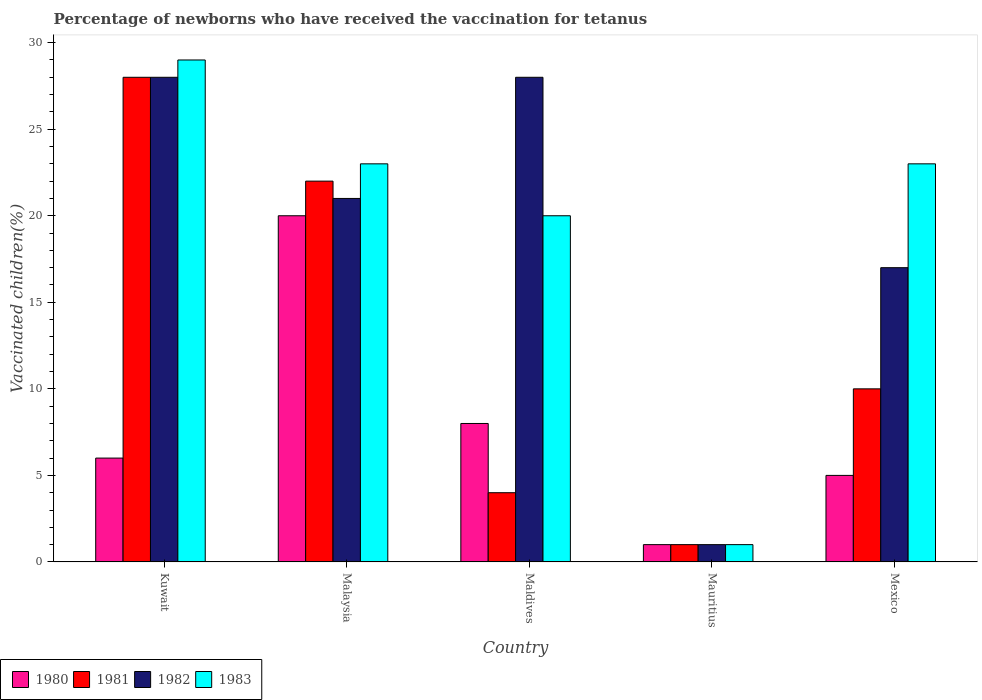How many different coloured bars are there?
Ensure brevity in your answer.  4. How many bars are there on the 3rd tick from the left?
Your answer should be compact. 4. What is the label of the 2nd group of bars from the left?
Make the answer very short. Malaysia. What is the percentage of vaccinated children in 1982 in Malaysia?
Ensure brevity in your answer.  21. Across all countries, what is the maximum percentage of vaccinated children in 1980?
Offer a very short reply. 20. In which country was the percentage of vaccinated children in 1980 maximum?
Offer a terse response. Malaysia. In which country was the percentage of vaccinated children in 1983 minimum?
Make the answer very short. Mauritius. What is the difference between the percentage of vaccinated children in 1983 in Malaysia and that in Mexico?
Your answer should be compact. 0. What is the ratio of the percentage of vaccinated children in 1983 in Maldives to that in Mexico?
Your answer should be compact. 0.87. Is the percentage of vaccinated children in 1982 in Malaysia less than that in Maldives?
Provide a short and direct response. Yes. Is the difference between the percentage of vaccinated children in 1981 in Kuwait and Mauritius greater than the difference between the percentage of vaccinated children in 1983 in Kuwait and Mauritius?
Make the answer very short. No. What is the difference between the highest and the second highest percentage of vaccinated children in 1981?
Provide a succinct answer. -18. What does the 3rd bar from the left in Mauritius represents?
Your response must be concise. 1982. What does the 4th bar from the right in Kuwait represents?
Provide a short and direct response. 1980. How many countries are there in the graph?
Provide a succinct answer. 5. What is the difference between two consecutive major ticks on the Y-axis?
Your answer should be very brief. 5. Are the values on the major ticks of Y-axis written in scientific E-notation?
Offer a terse response. No. Does the graph contain any zero values?
Make the answer very short. No. Does the graph contain grids?
Provide a short and direct response. No. Where does the legend appear in the graph?
Your answer should be very brief. Bottom left. How many legend labels are there?
Provide a succinct answer. 4. How are the legend labels stacked?
Offer a terse response. Horizontal. What is the title of the graph?
Ensure brevity in your answer.  Percentage of newborns who have received the vaccination for tetanus. What is the label or title of the X-axis?
Provide a short and direct response. Country. What is the label or title of the Y-axis?
Provide a short and direct response. Vaccinated children(%). What is the Vaccinated children(%) in 1980 in Kuwait?
Offer a terse response. 6. What is the Vaccinated children(%) of 1982 in Kuwait?
Your answer should be very brief. 28. What is the Vaccinated children(%) of 1983 in Kuwait?
Offer a terse response. 29. What is the Vaccinated children(%) in 1980 in Malaysia?
Provide a succinct answer. 20. What is the Vaccinated children(%) of 1981 in Malaysia?
Ensure brevity in your answer.  22. What is the Vaccinated children(%) of 1982 in Malaysia?
Your answer should be compact. 21. What is the Vaccinated children(%) of 1981 in Maldives?
Your answer should be compact. 4. What is the Vaccinated children(%) of 1982 in Maldives?
Ensure brevity in your answer.  28. What is the Vaccinated children(%) of 1983 in Maldives?
Ensure brevity in your answer.  20. What is the Vaccinated children(%) of 1980 in Mauritius?
Provide a succinct answer. 1. What is the Vaccinated children(%) in 1982 in Mauritius?
Provide a succinct answer. 1. What is the Vaccinated children(%) in 1983 in Mauritius?
Ensure brevity in your answer.  1. What is the Vaccinated children(%) of 1981 in Mexico?
Keep it short and to the point. 10. What is the Vaccinated children(%) of 1982 in Mexico?
Provide a short and direct response. 17. What is the Vaccinated children(%) in 1983 in Mexico?
Your answer should be compact. 23. Across all countries, what is the maximum Vaccinated children(%) of 1981?
Offer a terse response. 28. Across all countries, what is the maximum Vaccinated children(%) of 1983?
Offer a very short reply. 29. Across all countries, what is the minimum Vaccinated children(%) in 1980?
Offer a terse response. 1. What is the total Vaccinated children(%) of 1980 in the graph?
Make the answer very short. 40. What is the total Vaccinated children(%) of 1982 in the graph?
Provide a succinct answer. 95. What is the total Vaccinated children(%) in 1983 in the graph?
Offer a terse response. 96. What is the difference between the Vaccinated children(%) of 1983 in Kuwait and that in Malaysia?
Your response must be concise. 6. What is the difference between the Vaccinated children(%) in 1980 in Kuwait and that in Maldives?
Make the answer very short. -2. What is the difference between the Vaccinated children(%) of 1981 in Kuwait and that in Maldives?
Make the answer very short. 24. What is the difference between the Vaccinated children(%) of 1983 in Kuwait and that in Maldives?
Ensure brevity in your answer.  9. What is the difference between the Vaccinated children(%) of 1983 in Kuwait and that in Mauritius?
Offer a very short reply. 28. What is the difference between the Vaccinated children(%) in 1981 in Kuwait and that in Mexico?
Make the answer very short. 18. What is the difference between the Vaccinated children(%) of 1983 in Malaysia and that in Maldives?
Your answer should be very brief. 3. What is the difference between the Vaccinated children(%) in 1980 in Malaysia and that in Mauritius?
Keep it short and to the point. 19. What is the difference between the Vaccinated children(%) in 1983 in Malaysia and that in Mauritius?
Offer a terse response. 22. What is the difference between the Vaccinated children(%) in 1980 in Malaysia and that in Mexico?
Your answer should be very brief. 15. What is the difference between the Vaccinated children(%) in 1982 in Maldives and that in Mauritius?
Provide a succinct answer. 27. What is the difference between the Vaccinated children(%) of 1980 in Maldives and that in Mexico?
Offer a terse response. 3. What is the difference between the Vaccinated children(%) of 1981 in Maldives and that in Mexico?
Your answer should be compact. -6. What is the difference between the Vaccinated children(%) of 1982 in Maldives and that in Mexico?
Your response must be concise. 11. What is the difference between the Vaccinated children(%) of 1981 in Mauritius and that in Mexico?
Make the answer very short. -9. What is the difference between the Vaccinated children(%) of 1983 in Mauritius and that in Mexico?
Keep it short and to the point. -22. What is the difference between the Vaccinated children(%) of 1980 in Kuwait and the Vaccinated children(%) of 1981 in Malaysia?
Offer a very short reply. -16. What is the difference between the Vaccinated children(%) of 1980 in Kuwait and the Vaccinated children(%) of 1982 in Malaysia?
Provide a short and direct response. -15. What is the difference between the Vaccinated children(%) of 1980 in Kuwait and the Vaccinated children(%) of 1983 in Malaysia?
Provide a succinct answer. -17. What is the difference between the Vaccinated children(%) in 1981 in Kuwait and the Vaccinated children(%) in 1982 in Malaysia?
Your answer should be very brief. 7. What is the difference between the Vaccinated children(%) in 1981 in Kuwait and the Vaccinated children(%) in 1983 in Malaysia?
Offer a very short reply. 5. What is the difference between the Vaccinated children(%) of 1982 in Kuwait and the Vaccinated children(%) of 1983 in Malaysia?
Keep it short and to the point. 5. What is the difference between the Vaccinated children(%) in 1981 in Kuwait and the Vaccinated children(%) in 1982 in Maldives?
Provide a succinct answer. 0. What is the difference between the Vaccinated children(%) in 1982 in Kuwait and the Vaccinated children(%) in 1983 in Maldives?
Provide a succinct answer. 8. What is the difference between the Vaccinated children(%) of 1980 in Kuwait and the Vaccinated children(%) of 1981 in Mauritius?
Offer a terse response. 5. What is the difference between the Vaccinated children(%) in 1980 in Kuwait and the Vaccinated children(%) in 1983 in Mauritius?
Offer a very short reply. 5. What is the difference between the Vaccinated children(%) of 1981 in Kuwait and the Vaccinated children(%) of 1982 in Mauritius?
Provide a succinct answer. 27. What is the difference between the Vaccinated children(%) in 1980 in Kuwait and the Vaccinated children(%) in 1982 in Mexico?
Make the answer very short. -11. What is the difference between the Vaccinated children(%) of 1981 in Kuwait and the Vaccinated children(%) of 1982 in Mexico?
Provide a succinct answer. 11. What is the difference between the Vaccinated children(%) of 1982 in Kuwait and the Vaccinated children(%) of 1983 in Mexico?
Provide a short and direct response. 5. What is the difference between the Vaccinated children(%) in 1980 in Malaysia and the Vaccinated children(%) in 1981 in Maldives?
Offer a terse response. 16. What is the difference between the Vaccinated children(%) in 1980 in Malaysia and the Vaccinated children(%) in 1982 in Maldives?
Provide a succinct answer. -8. What is the difference between the Vaccinated children(%) of 1980 in Malaysia and the Vaccinated children(%) of 1983 in Maldives?
Offer a very short reply. 0. What is the difference between the Vaccinated children(%) in 1981 in Malaysia and the Vaccinated children(%) in 1983 in Maldives?
Provide a succinct answer. 2. What is the difference between the Vaccinated children(%) of 1982 in Malaysia and the Vaccinated children(%) of 1983 in Maldives?
Keep it short and to the point. 1. What is the difference between the Vaccinated children(%) of 1980 in Malaysia and the Vaccinated children(%) of 1981 in Mauritius?
Provide a short and direct response. 19. What is the difference between the Vaccinated children(%) of 1980 in Malaysia and the Vaccinated children(%) of 1983 in Mauritius?
Keep it short and to the point. 19. What is the difference between the Vaccinated children(%) of 1981 in Malaysia and the Vaccinated children(%) of 1982 in Mauritius?
Your answer should be very brief. 21. What is the difference between the Vaccinated children(%) of 1980 in Malaysia and the Vaccinated children(%) of 1981 in Mexico?
Your answer should be very brief. 10. What is the difference between the Vaccinated children(%) in 1980 in Malaysia and the Vaccinated children(%) in 1982 in Mexico?
Make the answer very short. 3. What is the difference between the Vaccinated children(%) in 1981 in Malaysia and the Vaccinated children(%) in 1982 in Mexico?
Ensure brevity in your answer.  5. What is the difference between the Vaccinated children(%) of 1982 in Malaysia and the Vaccinated children(%) of 1983 in Mexico?
Ensure brevity in your answer.  -2. What is the difference between the Vaccinated children(%) of 1980 in Maldives and the Vaccinated children(%) of 1981 in Mauritius?
Make the answer very short. 7. What is the difference between the Vaccinated children(%) in 1980 in Maldives and the Vaccinated children(%) in 1982 in Mauritius?
Offer a very short reply. 7. What is the difference between the Vaccinated children(%) in 1980 in Maldives and the Vaccinated children(%) in 1982 in Mexico?
Give a very brief answer. -9. What is the difference between the Vaccinated children(%) in 1980 in Maldives and the Vaccinated children(%) in 1983 in Mexico?
Your answer should be compact. -15. What is the difference between the Vaccinated children(%) in 1982 in Maldives and the Vaccinated children(%) in 1983 in Mexico?
Keep it short and to the point. 5. What is the difference between the Vaccinated children(%) in 1980 in Mauritius and the Vaccinated children(%) in 1982 in Mexico?
Give a very brief answer. -16. What is the difference between the Vaccinated children(%) in 1980 in Mauritius and the Vaccinated children(%) in 1983 in Mexico?
Make the answer very short. -22. What is the difference between the Vaccinated children(%) in 1981 in Mauritius and the Vaccinated children(%) in 1982 in Mexico?
Your response must be concise. -16. What is the difference between the Vaccinated children(%) in 1982 in Mauritius and the Vaccinated children(%) in 1983 in Mexico?
Your answer should be very brief. -22. What is the average Vaccinated children(%) of 1981 per country?
Your response must be concise. 13. What is the average Vaccinated children(%) in 1982 per country?
Offer a terse response. 19. What is the difference between the Vaccinated children(%) of 1980 and Vaccinated children(%) of 1982 in Kuwait?
Your response must be concise. -22. What is the difference between the Vaccinated children(%) of 1980 and Vaccinated children(%) of 1983 in Kuwait?
Offer a terse response. -23. What is the difference between the Vaccinated children(%) of 1980 and Vaccinated children(%) of 1981 in Malaysia?
Offer a very short reply. -2. What is the difference between the Vaccinated children(%) in 1980 and Vaccinated children(%) in 1983 in Malaysia?
Provide a short and direct response. -3. What is the difference between the Vaccinated children(%) of 1981 and Vaccinated children(%) of 1983 in Malaysia?
Ensure brevity in your answer.  -1. What is the difference between the Vaccinated children(%) of 1982 and Vaccinated children(%) of 1983 in Malaysia?
Make the answer very short. -2. What is the difference between the Vaccinated children(%) in 1980 and Vaccinated children(%) in 1981 in Maldives?
Your answer should be very brief. 4. What is the difference between the Vaccinated children(%) in 1981 and Vaccinated children(%) in 1982 in Maldives?
Ensure brevity in your answer.  -24. What is the difference between the Vaccinated children(%) in 1980 and Vaccinated children(%) in 1982 in Mauritius?
Give a very brief answer. 0. What is the difference between the Vaccinated children(%) of 1980 and Vaccinated children(%) of 1983 in Mauritius?
Ensure brevity in your answer.  0. What is the difference between the Vaccinated children(%) in 1981 and Vaccinated children(%) in 1982 in Mauritius?
Provide a succinct answer. 0. What is the difference between the Vaccinated children(%) of 1980 and Vaccinated children(%) of 1982 in Mexico?
Provide a succinct answer. -12. What is the difference between the Vaccinated children(%) in 1980 and Vaccinated children(%) in 1983 in Mexico?
Keep it short and to the point. -18. What is the difference between the Vaccinated children(%) of 1981 and Vaccinated children(%) of 1983 in Mexico?
Your response must be concise. -13. What is the ratio of the Vaccinated children(%) of 1980 in Kuwait to that in Malaysia?
Ensure brevity in your answer.  0.3. What is the ratio of the Vaccinated children(%) of 1981 in Kuwait to that in Malaysia?
Keep it short and to the point. 1.27. What is the ratio of the Vaccinated children(%) in 1982 in Kuwait to that in Malaysia?
Your answer should be very brief. 1.33. What is the ratio of the Vaccinated children(%) of 1983 in Kuwait to that in Malaysia?
Offer a very short reply. 1.26. What is the ratio of the Vaccinated children(%) in 1980 in Kuwait to that in Maldives?
Provide a short and direct response. 0.75. What is the ratio of the Vaccinated children(%) in 1982 in Kuwait to that in Maldives?
Offer a very short reply. 1. What is the ratio of the Vaccinated children(%) in 1983 in Kuwait to that in Maldives?
Your response must be concise. 1.45. What is the ratio of the Vaccinated children(%) of 1983 in Kuwait to that in Mauritius?
Ensure brevity in your answer.  29. What is the ratio of the Vaccinated children(%) in 1980 in Kuwait to that in Mexico?
Your response must be concise. 1.2. What is the ratio of the Vaccinated children(%) in 1982 in Kuwait to that in Mexico?
Your answer should be compact. 1.65. What is the ratio of the Vaccinated children(%) in 1983 in Kuwait to that in Mexico?
Make the answer very short. 1.26. What is the ratio of the Vaccinated children(%) of 1980 in Malaysia to that in Maldives?
Your response must be concise. 2.5. What is the ratio of the Vaccinated children(%) in 1982 in Malaysia to that in Maldives?
Keep it short and to the point. 0.75. What is the ratio of the Vaccinated children(%) of 1983 in Malaysia to that in Maldives?
Make the answer very short. 1.15. What is the ratio of the Vaccinated children(%) of 1980 in Malaysia to that in Mauritius?
Your answer should be very brief. 20. What is the ratio of the Vaccinated children(%) in 1982 in Malaysia to that in Mauritius?
Make the answer very short. 21. What is the ratio of the Vaccinated children(%) of 1982 in Malaysia to that in Mexico?
Your answer should be very brief. 1.24. What is the ratio of the Vaccinated children(%) of 1983 in Malaysia to that in Mexico?
Your answer should be compact. 1. What is the ratio of the Vaccinated children(%) of 1983 in Maldives to that in Mauritius?
Provide a succinct answer. 20. What is the ratio of the Vaccinated children(%) of 1980 in Maldives to that in Mexico?
Your response must be concise. 1.6. What is the ratio of the Vaccinated children(%) of 1981 in Maldives to that in Mexico?
Provide a short and direct response. 0.4. What is the ratio of the Vaccinated children(%) in 1982 in Maldives to that in Mexico?
Make the answer very short. 1.65. What is the ratio of the Vaccinated children(%) in 1983 in Maldives to that in Mexico?
Offer a terse response. 0.87. What is the ratio of the Vaccinated children(%) in 1980 in Mauritius to that in Mexico?
Ensure brevity in your answer.  0.2. What is the ratio of the Vaccinated children(%) of 1982 in Mauritius to that in Mexico?
Offer a terse response. 0.06. What is the ratio of the Vaccinated children(%) of 1983 in Mauritius to that in Mexico?
Make the answer very short. 0.04. What is the difference between the highest and the second highest Vaccinated children(%) in 1980?
Your answer should be very brief. 12. What is the difference between the highest and the second highest Vaccinated children(%) in 1983?
Provide a succinct answer. 6. What is the difference between the highest and the lowest Vaccinated children(%) in 1983?
Your answer should be compact. 28. 